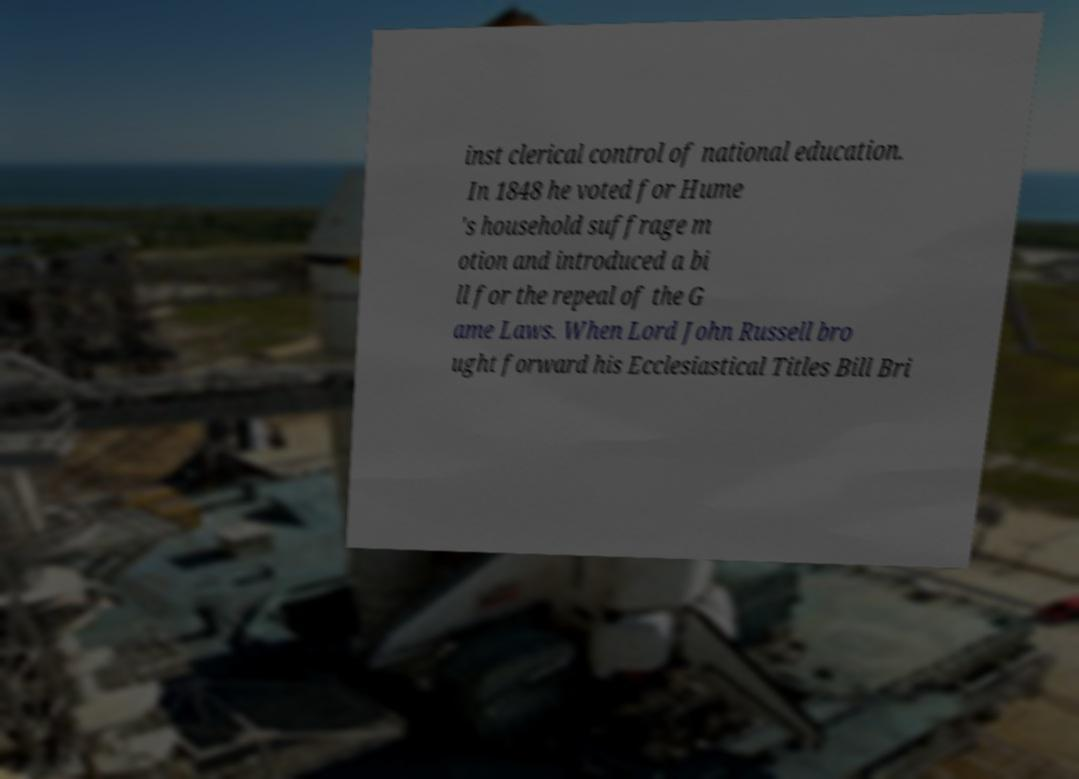What messages or text are displayed in this image? I need them in a readable, typed format. inst clerical control of national education. In 1848 he voted for Hume 's household suffrage m otion and introduced a bi ll for the repeal of the G ame Laws. When Lord John Russell bro ught forward his Ecclesiastical Titles Bill Bri 